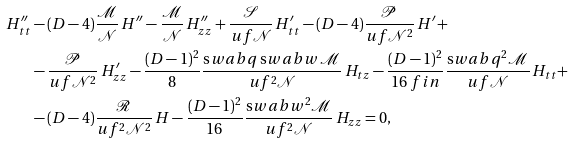Convert formula to latex. <formula><loc_0><loc_0><loc_500><loc_500>H ^ { \prime \prime } _ { t t } & - ( D - 4 ) \frac { \mathcal { M } } { \mathcal { N } } \, H ^ { \prime \prime } - \frac { \mathcal { M } } { \mathcal { N } } \, H ^ { \prime \prime } _ { z z } + \frac { \mathcal { S } } { u f \mathcal { N } } \, H ^ { \prime } _ { t t } - ( D - 4 ) \frac { \mathcal { P } } { u f \mathcal { N } ^ { 2 } } \, H ^ { \prime } + \\ & - \frac { \mathcal { P } } { u f \mathcal { N } ^ { 2 } } \, H ^ { \prime } _ { z z } - \frac { ( D - 1 ) ^ { 2 } } { 8 } \frac { \text  swab{q} \, \text  swab{w} \, \mathcal { M } } { u f ^ { 2 } \mathcal { N } } \, H _ { t z } - \frac { ( D - 1 ) ^ { 2 } } { 1 6 \ f i n } \frac { \text  swab{q} ^ { 2 } \mathcal { M } } { u f \mathcal { N } } \, H _ { t t } + \\ & - ( D - 4 ) \frac { \mathcal { R } } { u f ^ { 2 } \mathcal { N } ^ { 2 } } \, H - \frac { ( D - 1 ) ^ { 2 } } { 1 6 } \frac { \text  swab{w} ^ { 2 } \mathcal { M } } { u f ^ { 2 } \mathcal { N } } \, H _ { z z } = 0 ,</formula> 